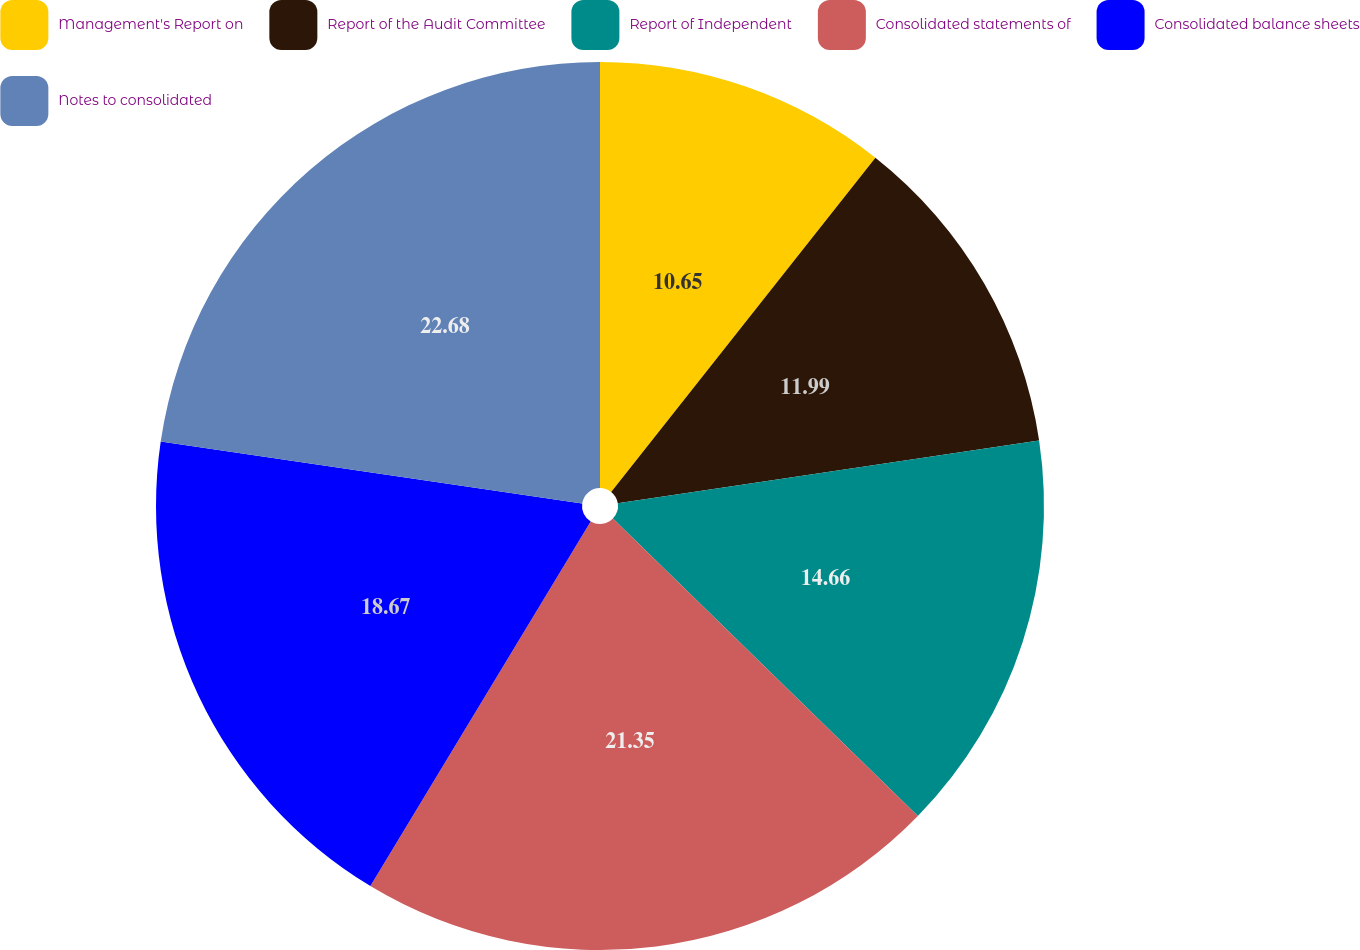Convert chart to OTSL. <chart><loc_0><loc_0><loc_500><loc_500><pie_chart><fcel>Management's Report on<fcel>Report of the Audit Committee<fcel>Report of Independent<fcel>Consolidated statements of<fcel>Consolidated balance sheets<fcel>Notes to consolidated<nl><fcel>10.65%<fcel>11.99%<fcel>14.66%<fcel>21.35%<fcel>18.67%<fcel>22.68%<nl></chart> 